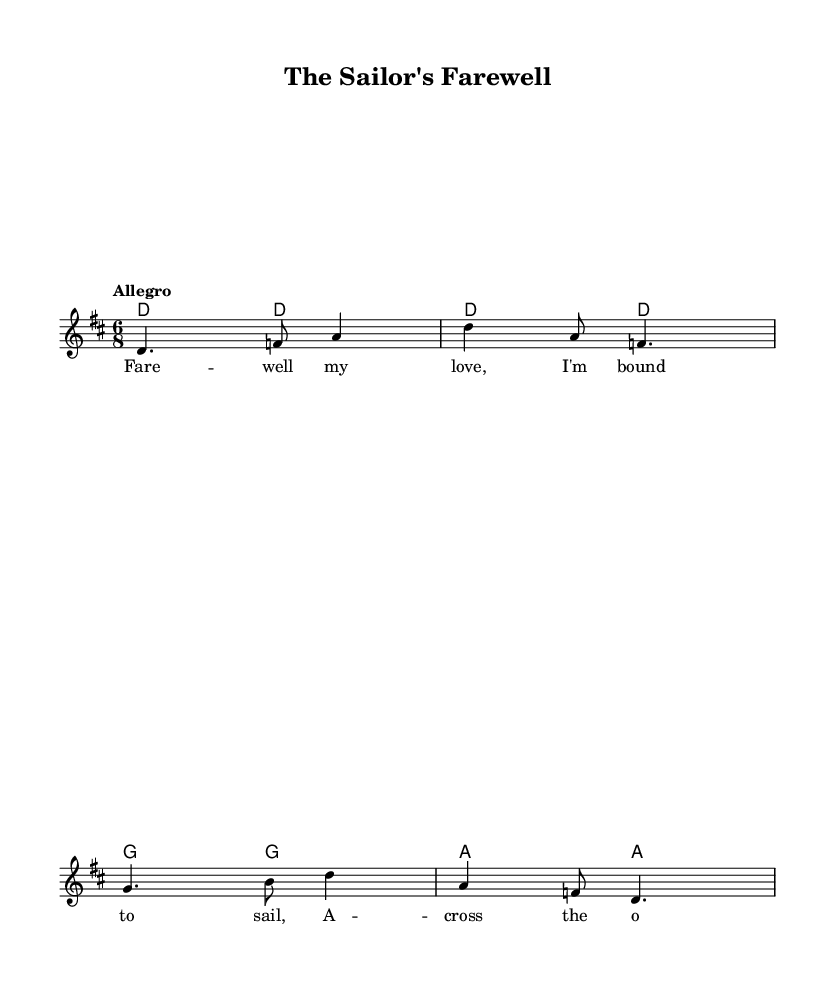What is the key signature of this music? The key signature is D major, which has two sharps (F# and C#). This can be identified by looking at the key signature section at the beginning of the staff.
Answer: D major What is the time signature of this piece? The time signature is 6/8, indicated at the beginning of the music. This means there are six eighth notes in each measure, with a strong emphasis on the first and fourth beats.
Answer: 6/8 What is the tempo marking indicated in the score? The tempo marking is "Allegro," which typically means to play quickly and lively. The tempo is specified directly below the clef at the beginning of the piece.
Answer: Allegro How many measures are in the melody? The melody consists of four measures, each separated by vertical bar lines on the staff. Counting these bars gives the total number of measures in the melody.
Answer: 4 What type of song is "The Sailor's Farewell"? "The Sailor's Farewell" is classified as a sea shanty, commonly associated with sailors and maritime activities. The lyrical content and context indicate this tradition.
Answer: Sea shanty What is the first line of the lyrics? The first line of the lyrics is "Fare -- well my love, I'm bound to sail." This can be found in the lyric section beneath the melody staff, indicating the text set to the music.
Answer: Fare -- well my love, I'm bound to sail 